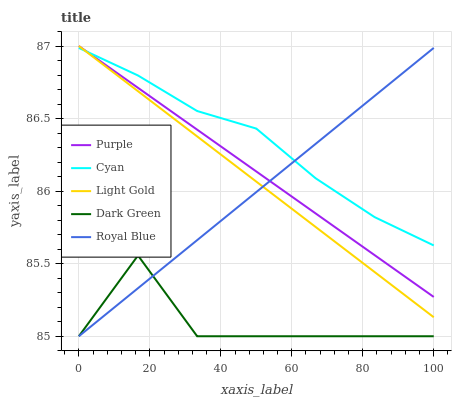Does Dark Green have the minimum area under the curve?
Answer yes or no. Yes. Does Cyan have the maximum area under the curve?
Answer yes or no. Yes. Does Light Gold have the minimum area under the curve?
Answer yes or no. No. Does Light Gold have the maximum area under the curve?
Answer yes or no. No. Is Purple the smoothest?
Answer yes or no. Yes. Is Dark Green the roughest?
Answer yes or no. Yes. Is Cyan the smoothest?
Answer yes or no. No. Is Cyan the roughest?
Answer yes or no. No. Does Light Gold have the lowest value?
Answer yes or no. No. Does Light Gold have the highest value?
Answer yes or no. Yes. Does Cyan have the highest value?
Answer yes or no. No. Is Dark Green less than Purple?
Answer yes or no. Yes. Is Light Gold greater than Dark Green?
Answer yes or no. Yes. Does Dark Green intersect Royal Blue?
Answer yes or no. Yes. Is Dark Green less than Royal Blue?
Answer yes or no. No. Is Dark Green greater than Royal Blue?
Answer yes or no. No. Does Dark Green intersect Purple?
Answer yes or no. No. 